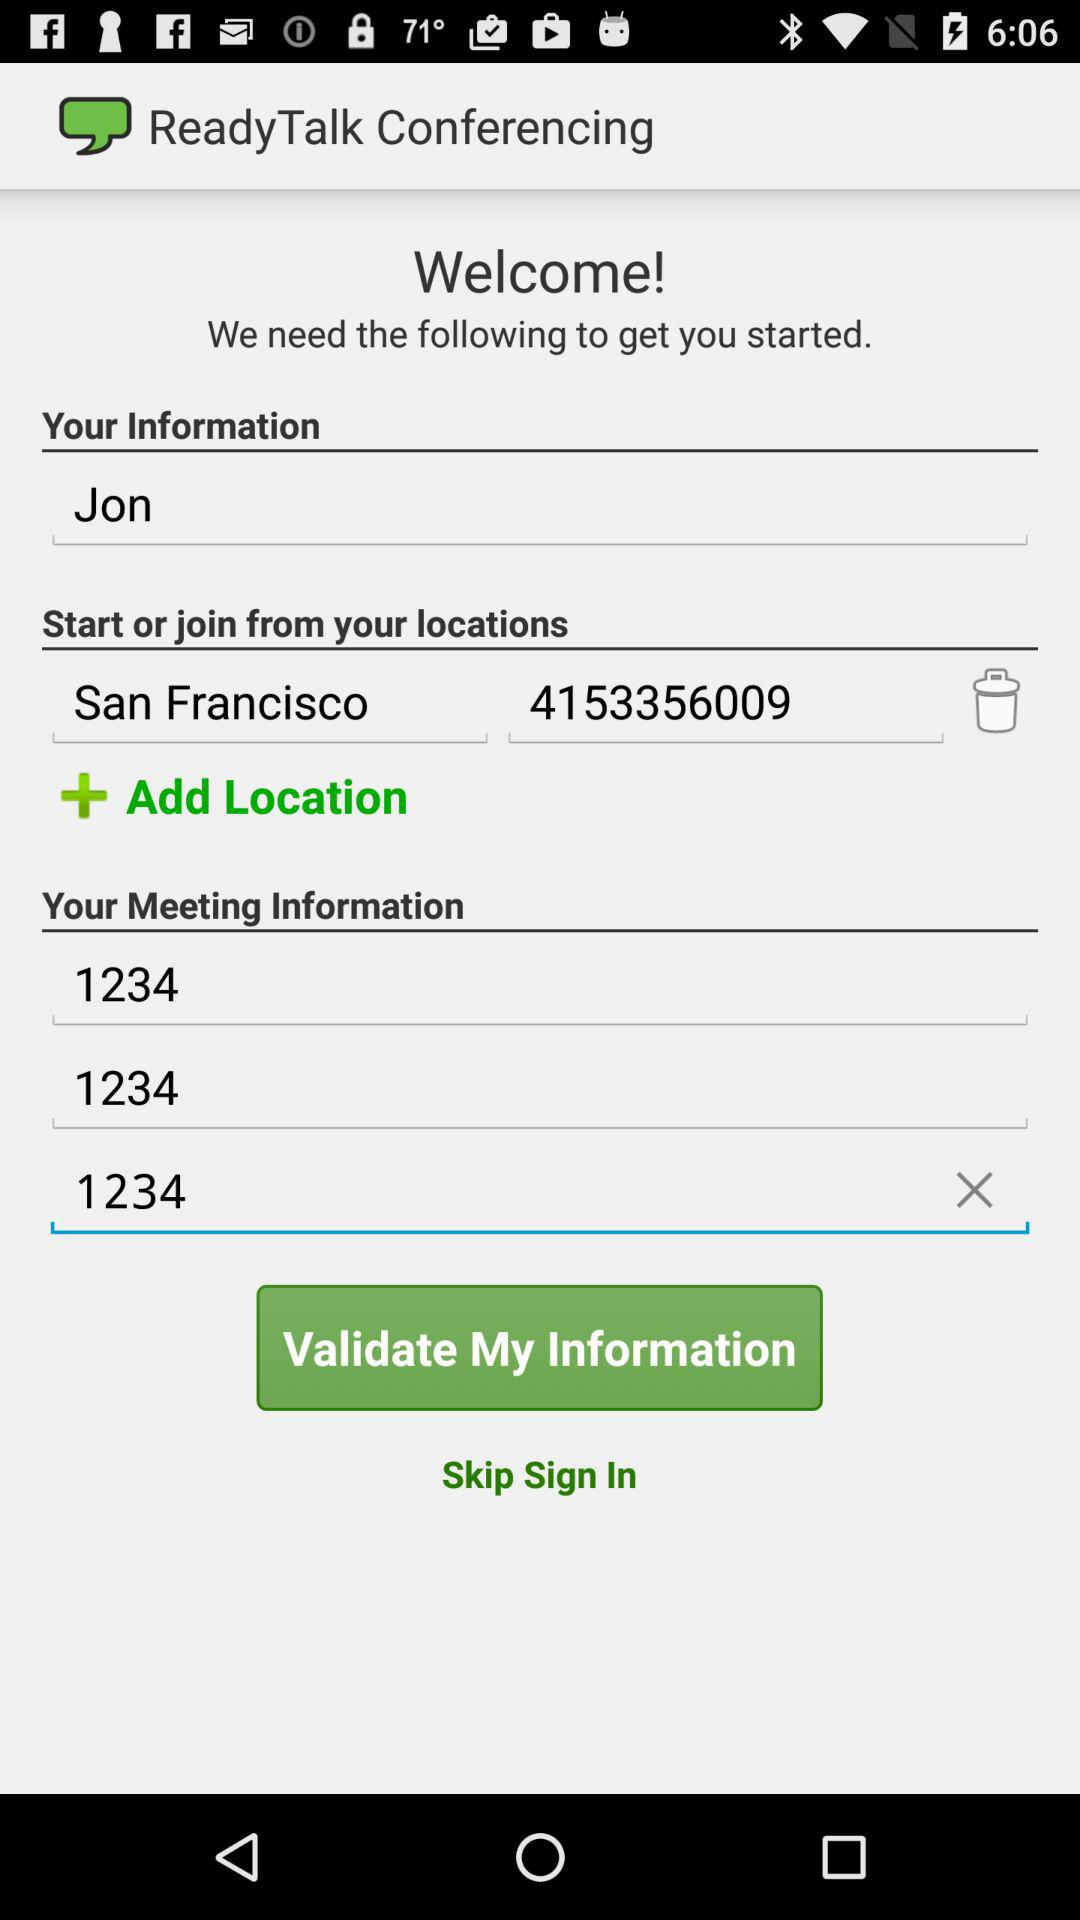What is the number? The numbers are 4153356009 and 1234. 